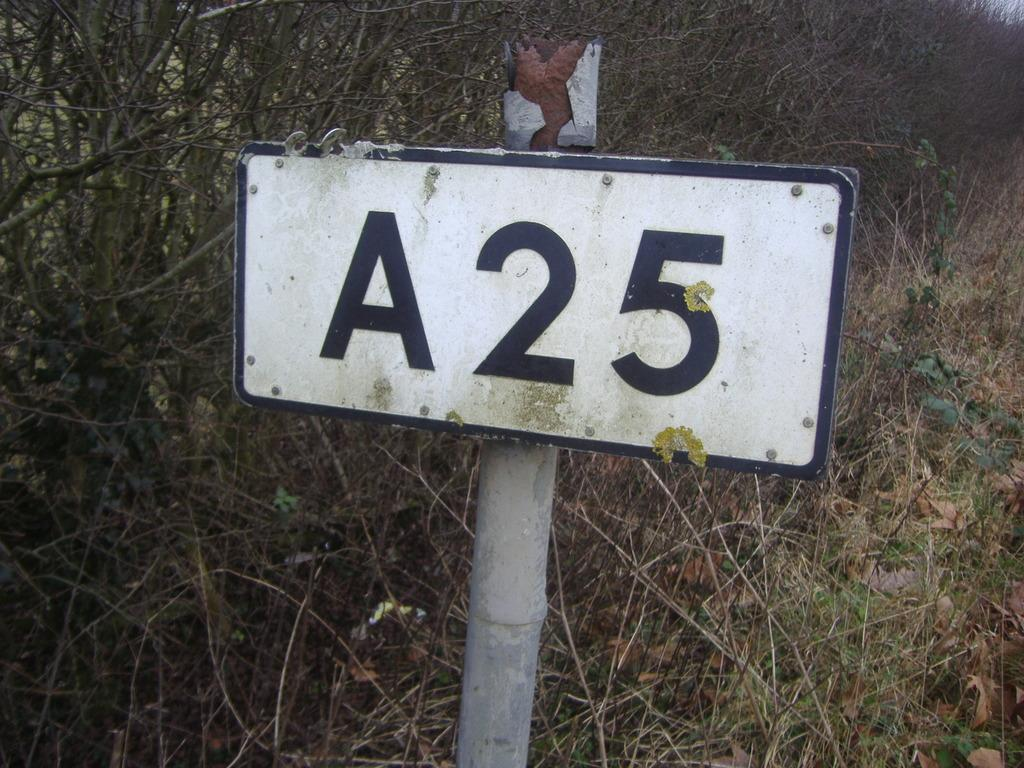What is attached to the pole in the image? There is a number plate attached to the pole in the image. What can be seen in the background of the image? There are plants and grass visible in the background of the image. What type of cattle can be seen grazing in the background of the image? There are no cattle present in the image; it only features a pole with a number plate and plants and grass in the background. 